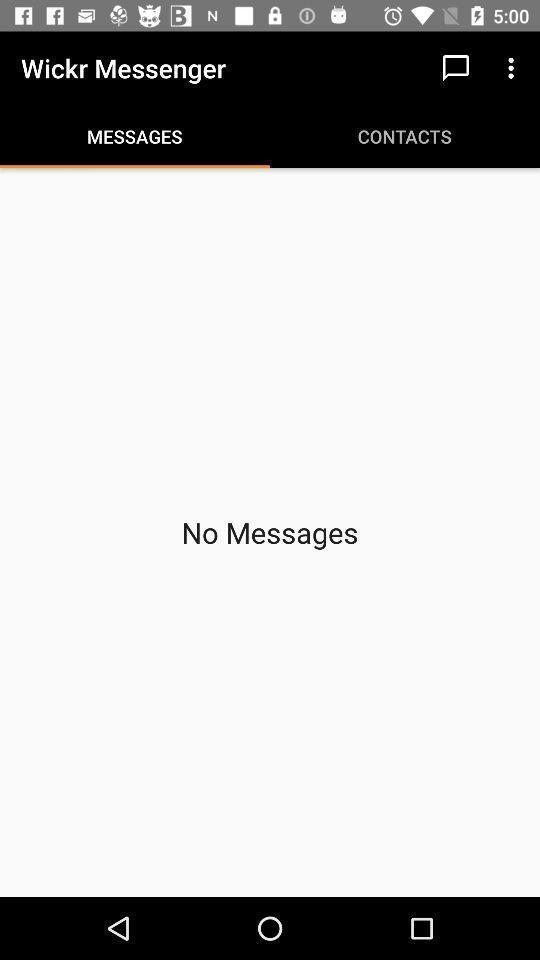Describe the visual elements of this screenshot. Screen page of a messaging app. 